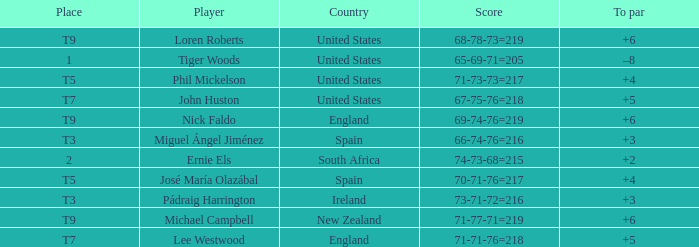What is Player, when Place is "1"? Tiger Woods. 